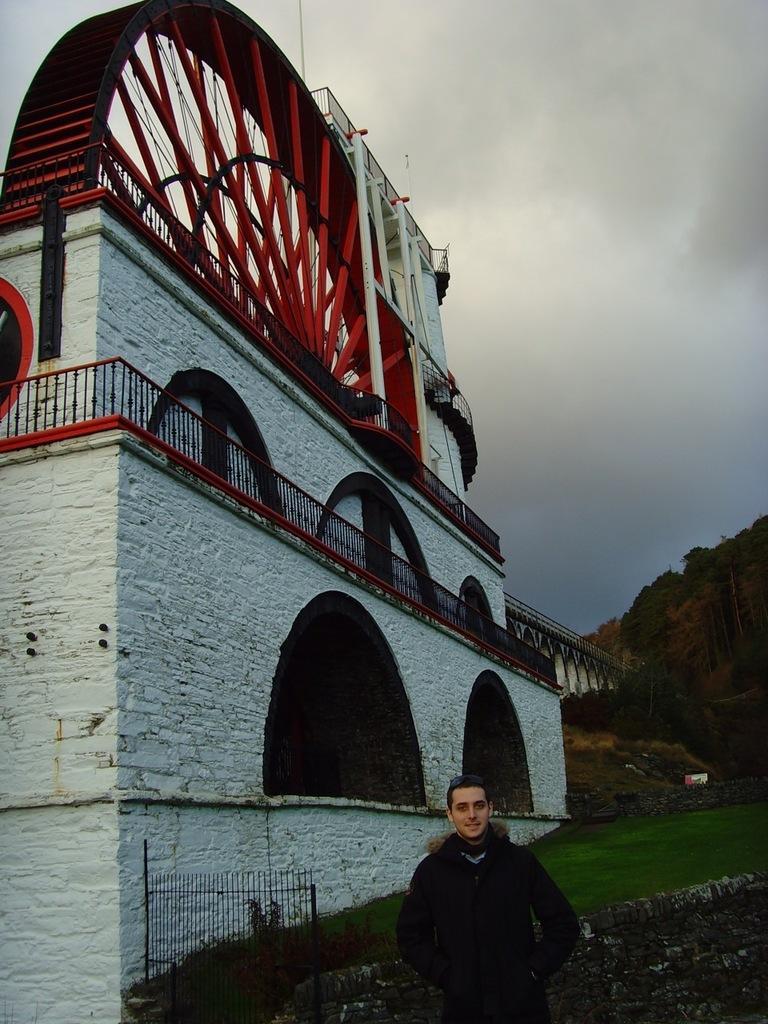Can you describe this image briefly? In this image we can see a person, a wall, a building, fences, grass, a bridge, few mountains and some clouds in the sky. 